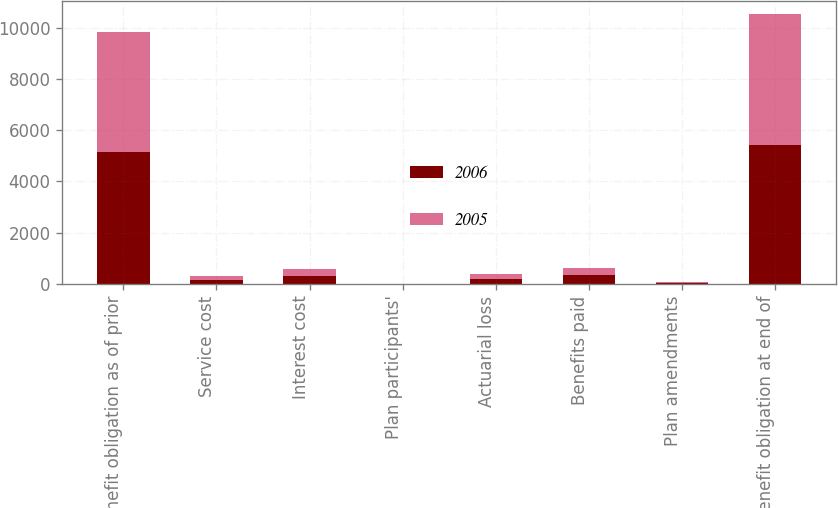<chart> <loc_0><loc_0><loc_500><loc_500><stacked_bar_chart><ecel><fcel>Benefit obligation as of prior<fcel>Service cost<fcel>Interest cost<fcel>Plan participants'<fcel>Actuarial loss<fcel>Benefits paid<fcel>Plan amendments<fcel>Benefit obligation at end of<nl><fcel>2006<fcel>5133<fcel>147<fcel>291<fcel>3<fcel>172<fcel>354<fcel>12<fcel>5406<nl><fcel>2005<fcel>4705<fcel>138<fcel>277<fcel>2<fcel>200<fcel>280<fcel>46<fcel>5133<nl></chart> 